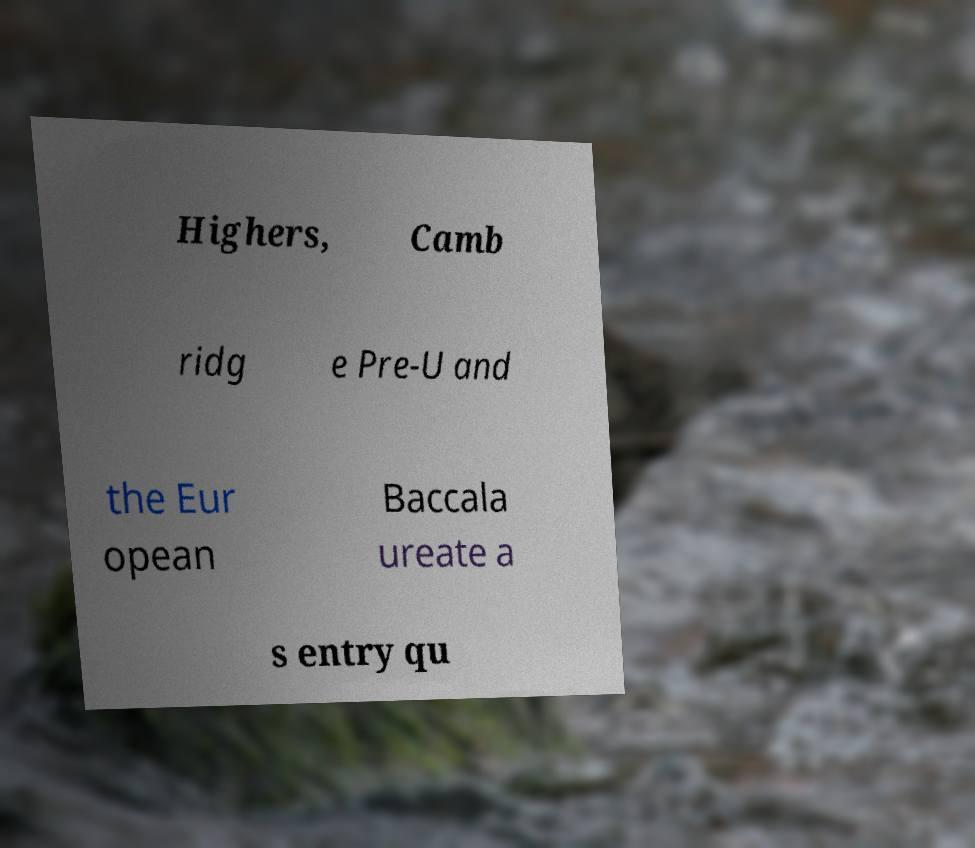Can you read and provide the text displayed in the image?This photo seems to have some interesting text. Can you extract and type it out for me? Highers, Camb ridg e Pre-U and the Eur opean Baccala ureate a s entry qu 